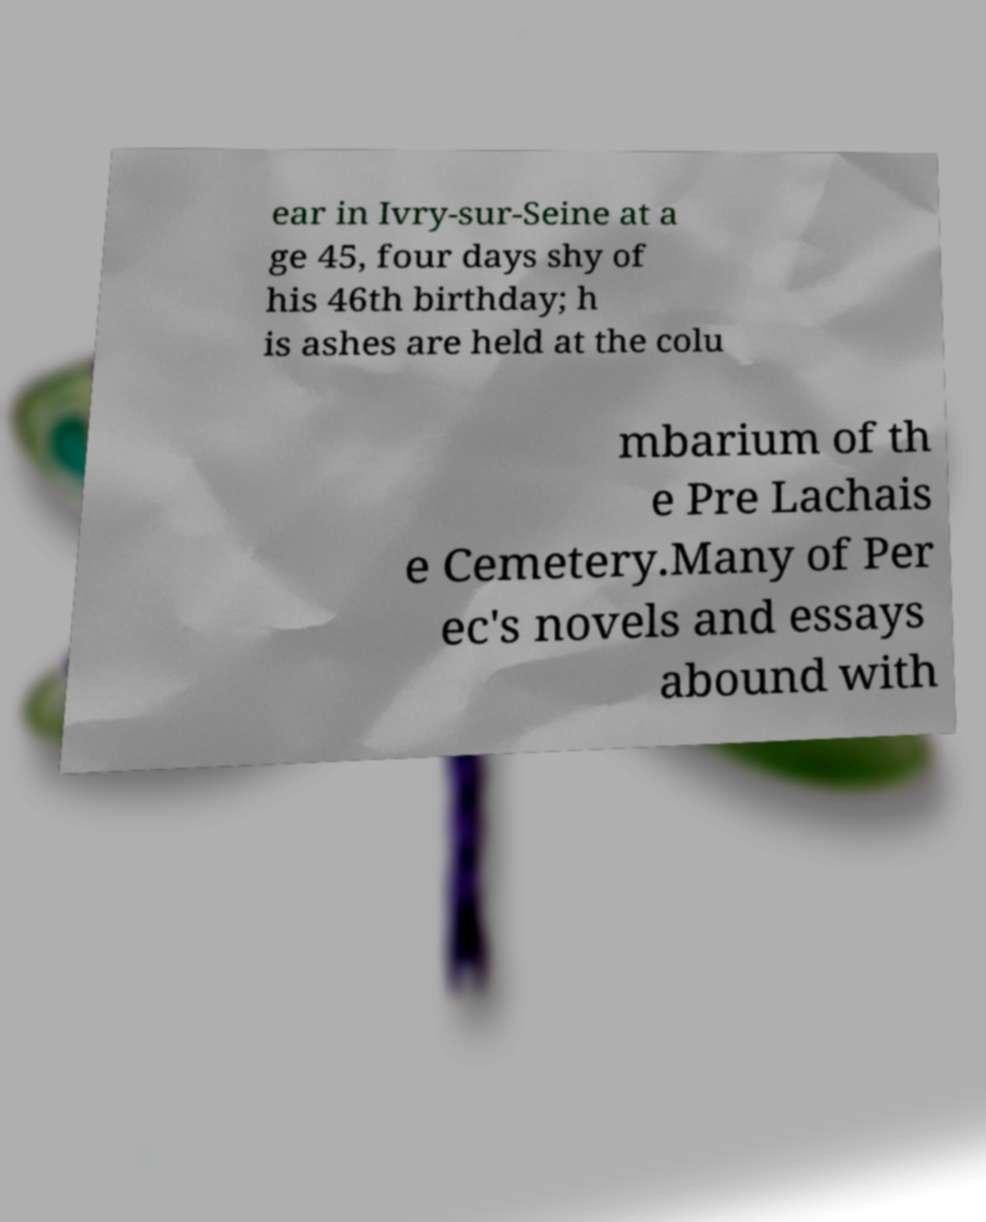Please identify and transcribe the text found in this image. ear in Ivry-sur-Seine at a ge 45, four days shy of his 46th birthday; h is ashes are held at the colu mbarium of th e Pre Lachais e Cemetery.Many of Per ec's novels and essays abound with 